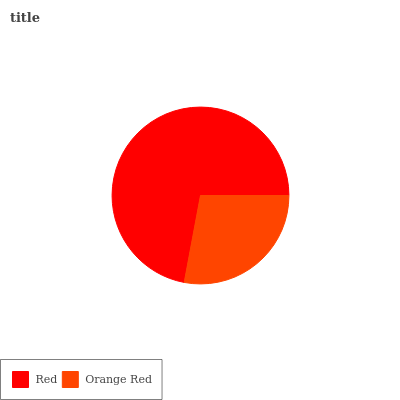Is Orange Red the minimum?
Answer yes or no. Yes. Is Red the maximum?
Answer yes or no. Yes. Is Orange Red the maximum?
Answer yes or no. No. Is Red greater than Orange Red?
Answer yes or no. Yes. Is Orange Red less than Red?
Answer yes or no. Yes. Is Orange Red greater than Red?
Answer yes or no. No. Is Red less than Orange Red?
Answer yes or no. No. Is Red the high median?
Answer yes or no. Yes. Is Orange Red the low median?
Answer yes or no. Yes. Is Orange Red the high median?
Answer yes or no. No. Is Red the low median?
Answer yes or no. No. 